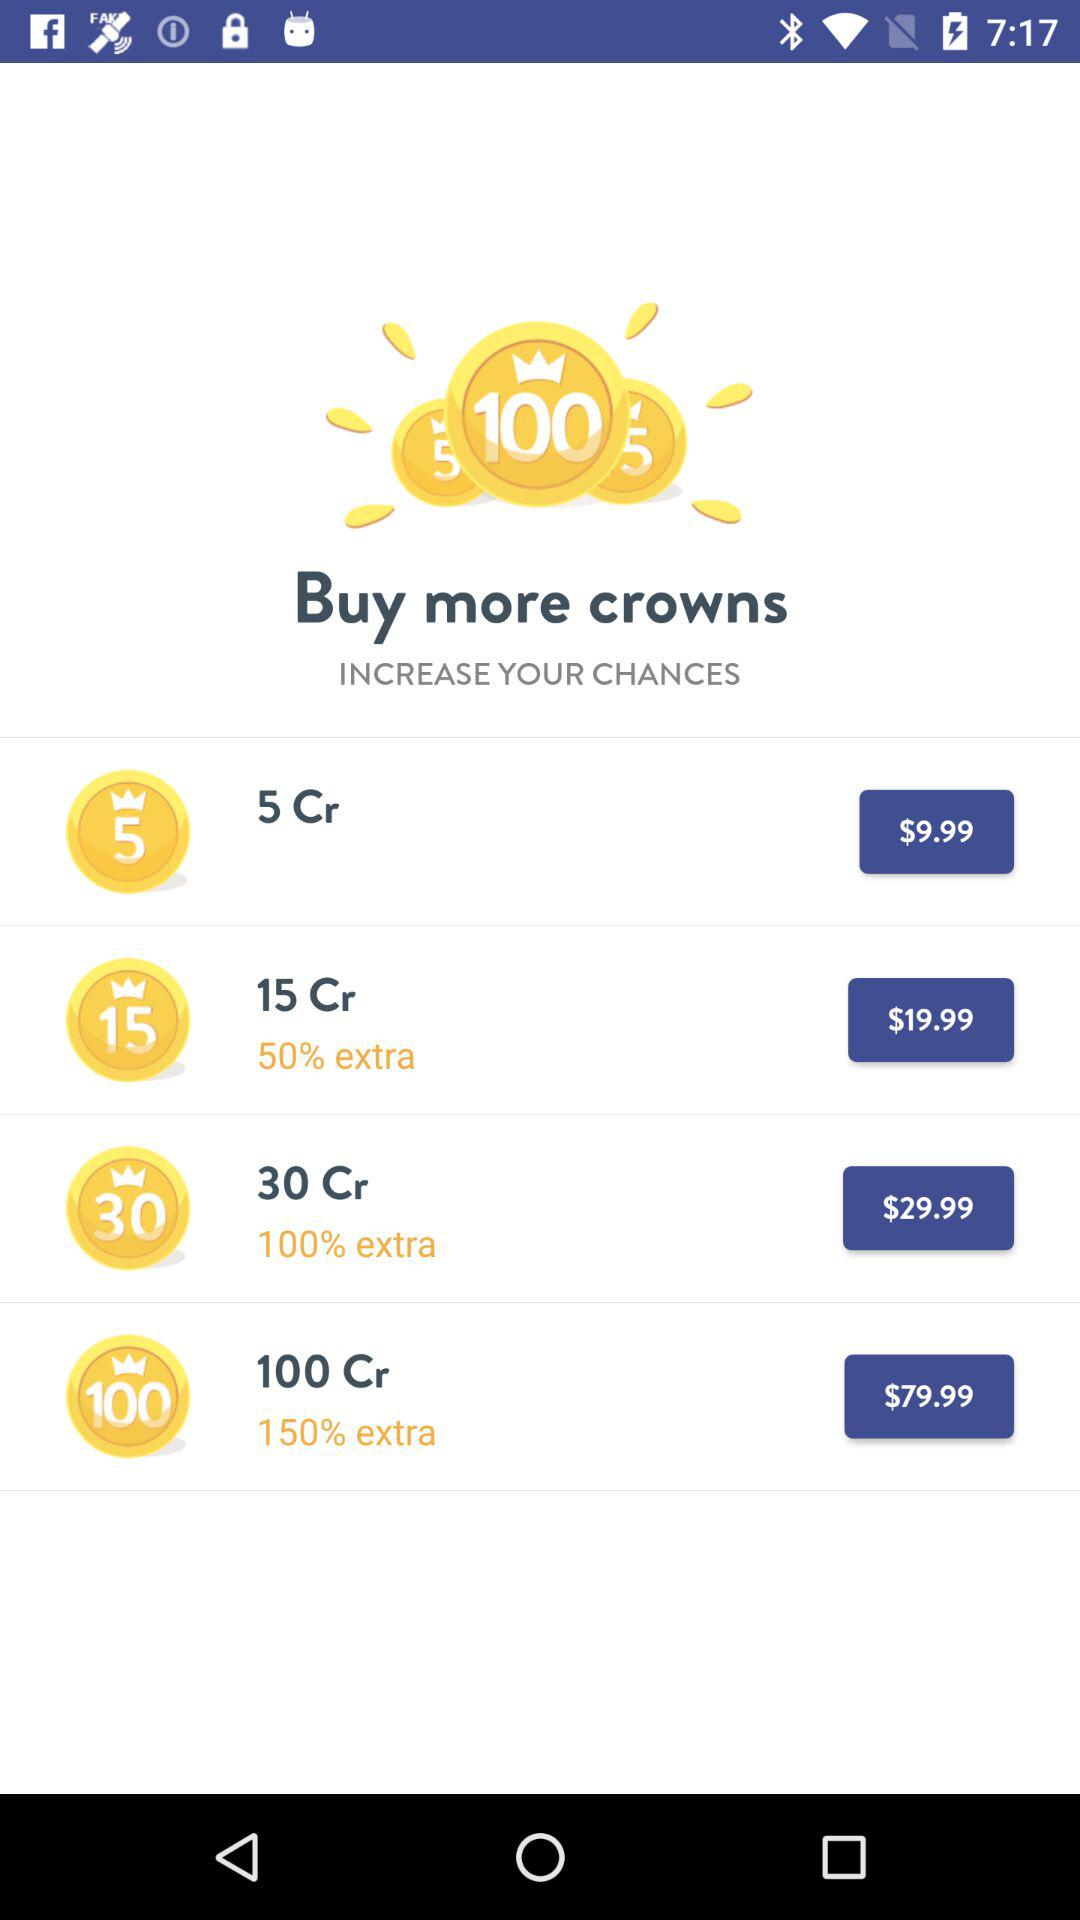How many more crowns do you get for the 100 Cr pack than the 5 Cr pack?
Answer the question using a single word or phrase. 95 